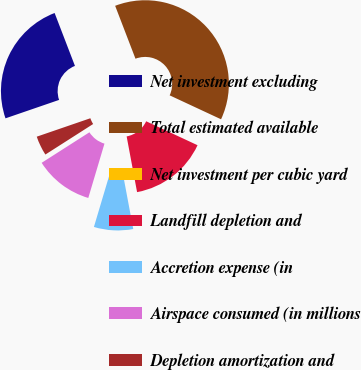<chart> <loc_0><loc_0><loc_500><loc_500><pie_chart><fcel>Net investment excluding<fcel>Total estimated available<fcel>Net investment per cubic yard<fcel>Landfill depletion and<fcel>Accretion expense (in<fcel>Airspace consumed (in millions<fcel>Depletion amortization and<nl><fcel>24.43%<fcel>37.78%<fcel>0.0%<fcel>15.11%<fcel>7.56%<fcel>11.34%<fcel>3.78%<nl></chart> 